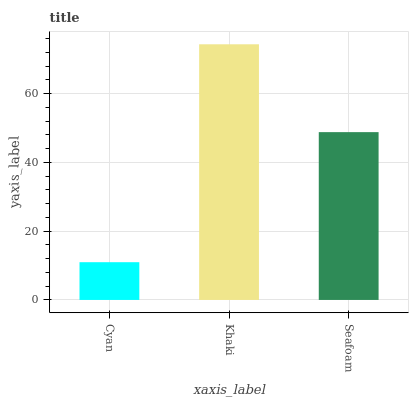Is Cyan the minimum?
Answer yes or no. Yes. Is Khaki the maximum?
Answer yes or no. Yes. Is Seafoam the minimum?
Answer yes or no. No. Is Seafoam the maximum?
Answer yes or no. No. Is Khaki greater than Seafoam?
Answer yes or no. Yes. Is Seafoam less than Khaki?
Answer yes or no. Yes. Is Seafoam greater than Khaki?
Answer yes or no. No. Is Khaki less than Seafoam?
Answer yes or no. No. Is Seafoam the high median?
Answer yes or no. Yes. Is Seafoam the low median?
Answer yes or no. Yes. Is Cyan the high median?
Answer yes or no. No. Is Khaki the low median?
Answer yes or no. No. 